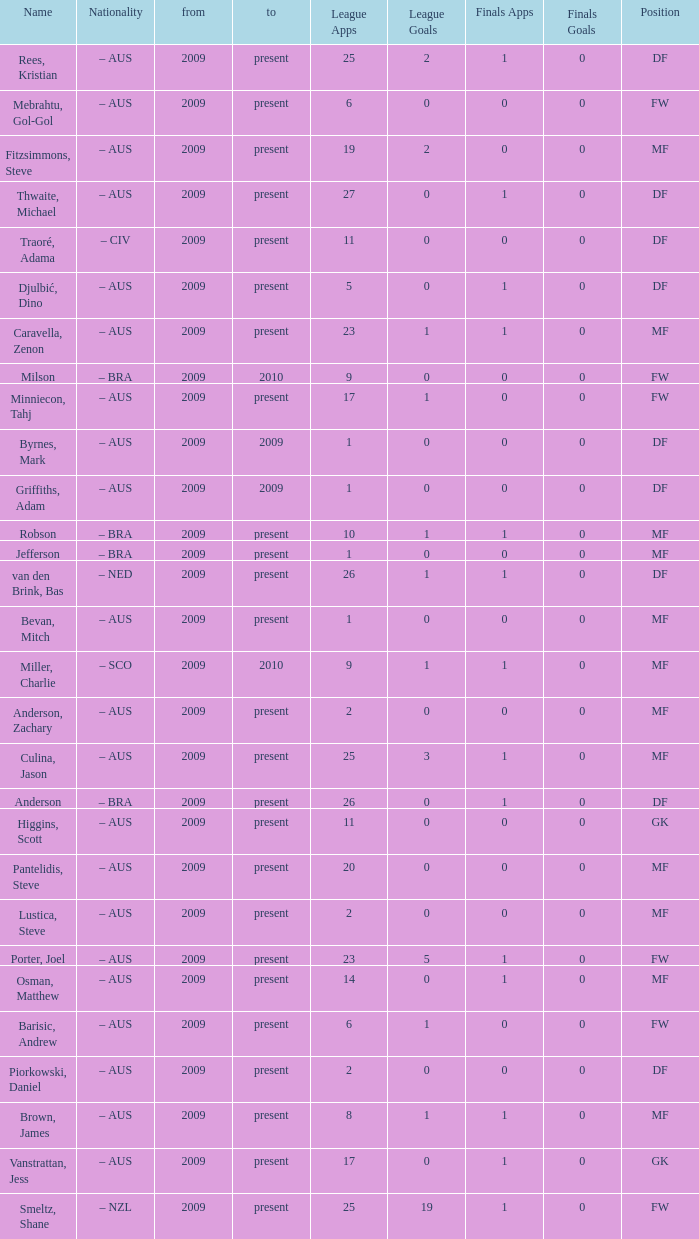Name the to for 19 league apps Present. 